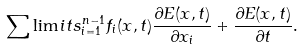<formula> <loc_0><loc_0><loc_500><loc_500>\sum \lim i t s _ { i = 1 } ^ { n - 1 } f _ { i } ( { x } , t ) \frac { \partial E ( { x } , t ) } { \partial x _ { i } } + \frac { \partial E ( { x } , t ) } { \partial t } .</formula> 